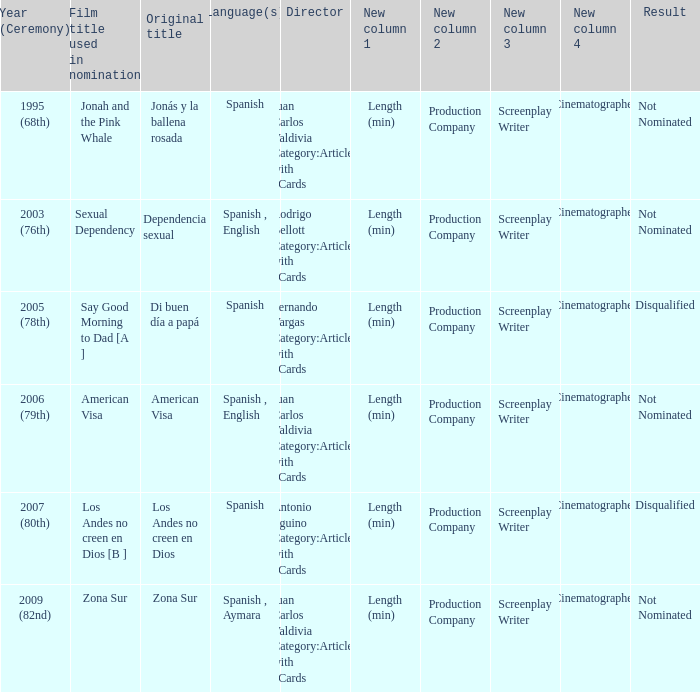When was zona sur nominated? 2009 (82nd). 